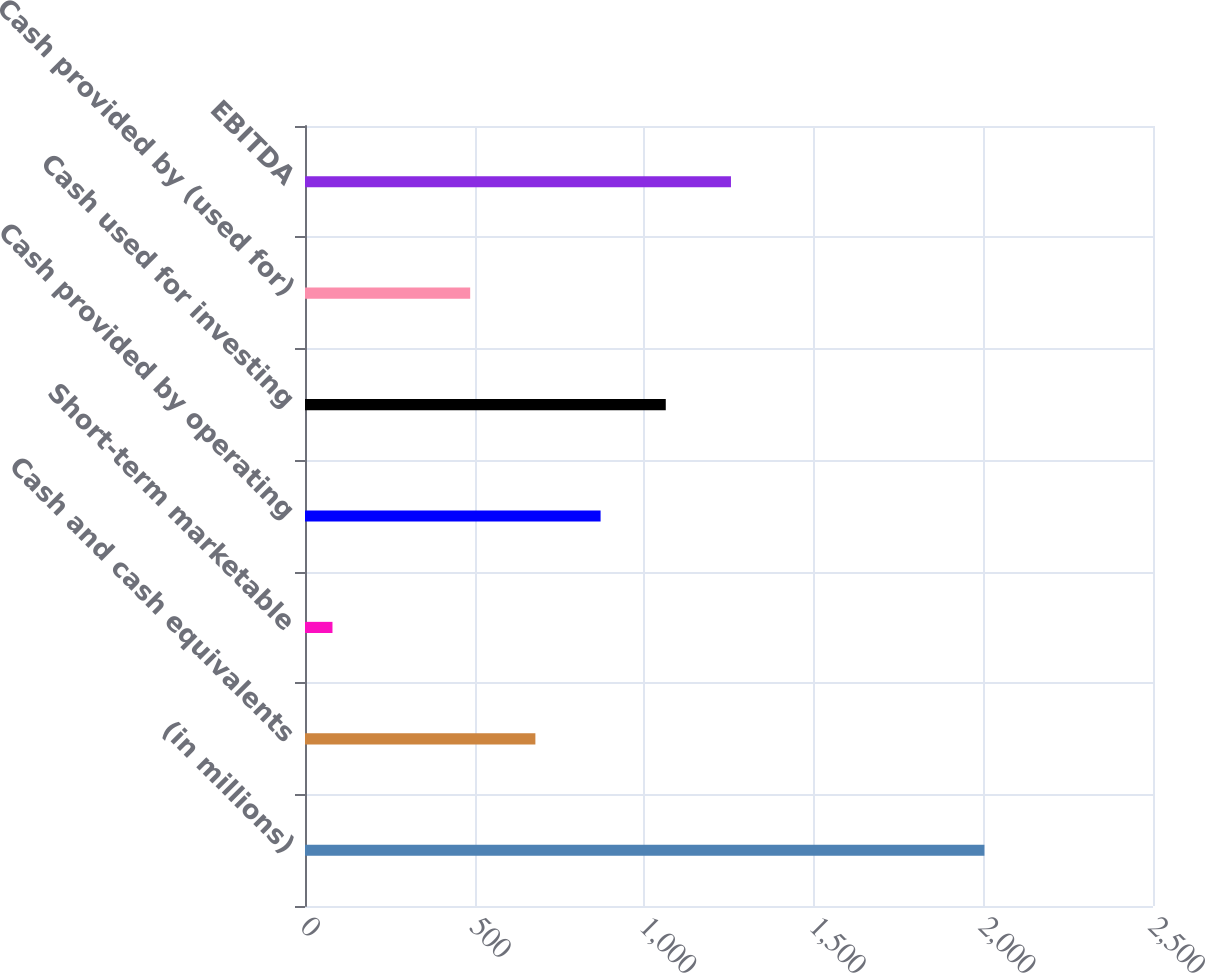Convert chart. <chart><loc_0><loc_0><loc_500><loc_500><bar_chart><fcel>(in millions)<fcel>Cash and cash equivalents<fcel>Short-term marketable<fcel>Cash provided by operating<fcel>Cash used for investing<fcel>Cash provided by (used for)<fcel>EBITDA<nl><fcel>2003<fcel>679.2<fcel>81<fcel>871.4<fcel>1063.6<fcel>487<fcel>1255.8<nl></chart> 